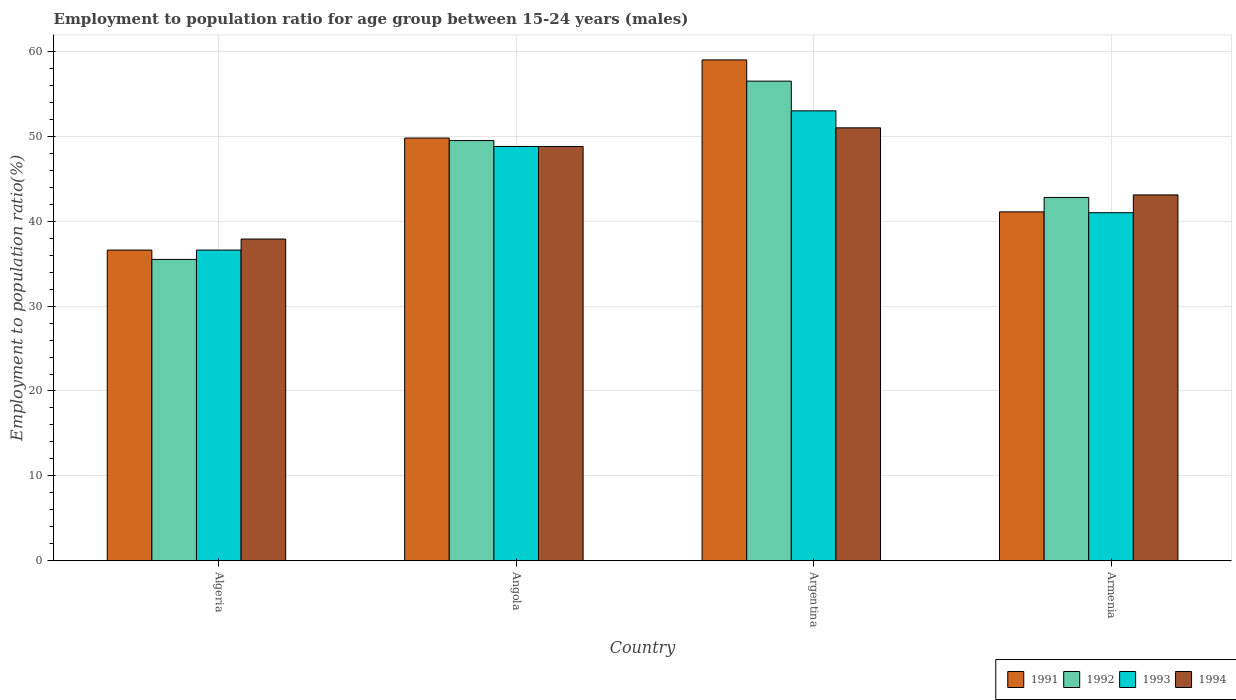How many bars are there on the 3rd tick from the left?
Ensure brevity in your answer.  4. How many bars are there on the 1st tick from the right?
Offer a very short reply. 4. What is the label of the 1st group of bars from the left?
Provide a short and direct response. Algeria. What is the employment to population ratio in 1994 in Argentina?
Ensure brevity in your answer.  51. Across all countries, what is the maximum employment to population ratio in 1991?
Offer a very short reply. 59. Across all countries, what is the minimum employment to population ratio in 1991?
Give a very brief answer. 36.6. In which country was the employment to population ratio in 1993 minimum?
Your answer should be very brief. Algeria. What is the total employment to population ratio in 1991 in the graph?
Offer a very short reply. 186.5. What is the difference between the employment to population ratio in 1994 in Armenia and the employment to population ratio in 1992 in Angola?
Your answer should be compact. -6.4. What is the average employment to population ratio in 1991 per country?
Provide a succinct answer. 46.62. What is the difference between the employment to population ratio of/in 1993 and employment to population ratio of/in 1992 in Algeria?
Your response must be concise. 1.1. What is the ratio of the employment to population ratio in 1994 in Angola to that in Argentina?
Your answer should be very brief. 0.96. Is the difference between the employment to population ratio in 1993 in Algeria and Angola greater than the difference between the employment to population ratio in 1992 in Algeria and Angola?
Keep it short and to the point. Yes. What is the difference between the highest and the second highest employment to population ratio in 1991?
Give a very brief answer. -9.2. What is the difference between the highest and the lowest employment to population ratio in 1994?
Your answer should be compact. 13.1. What does the 3rd bar from the left in Armenia represents?
Offer a terse response. 1993. Is it the case that in every country, the sum of the employment to population ratio in 1993 and employment to population ratio in 1991 is greater than the employment to population ratio in 1994?
Your response must be concise. Yes. Does the graph contain any zero values?
Make the answer very short. No. Where does the legend appear in the graph?
Provide a succinct answer. Bottom right. What is the title of the graph?
Offer a terse response. Employment to population ratio for age group between 15-24 years (males). What is the label or title of the X-axis?
Ensure brevity in your answer.  Country. What is the label or title of the Y-axis?
Your answer should be very brief. Employment to population ratio(%). What is the Employment to population ratio(%) in 1991 in Algeria?
Your response must be concise. 36.6. What is the Employment to population ratio(%) of 1992 in Algeria?
Give a very brief answer. 35.5. What is the Employment to population ratio(%) of 1993 in Algeria?
Your answer should be compact. 36.6. What is the Employment to population ratio(%) of 1994 in Algeria?
Make the answer very short. 37.9. What is the Employment to population ratio(%) of 1991 in Angola?
Offer a very short reply. 49.8. What is the Employment to population ratio(%) in 1992 in Angola?
Provide a succinct answer. 49.5. What is the Employment to population ratio(%) of 1993 in Angola?
Your response must be concise. 48.8. What is the Employment to population ratio(%) of 1994 in Angola?
Offer a terse response. 48.8. What is the Employment to population ratio(%) in 1992 in Argentina?
Keep it short and to the point. 56.5. What is the Employment to population ratio(%) of 1993 in Argentina?
Your answer should be very brief. 53. What is the Employment to population ratio(%) of 1994 in Argentina?
Your answer should be very brief. 51. What is the Employment to population ratio(%) in 1991 in Armenia?
Offer a very short reply. 41.1. What is the Employment to population ratio(%) in 1992 in Armenia?
Ensure brevity in your answer.  42.8. What is the Employment to population ratio(%) in 1994 in Armenia?
Provide a short and direct response. 43.1. Across all countries, what is the maximum Employment to population ratio(%) in 1992?
Keep it short and to the point. 56.5. Across all countries, what is the maximum Employment to population ratio(%) in 1994?
Offer a very short reply. 51. Across all countries, what is the minimum Employment to population ratio(%) in 1991?
Keep it short and to the point. 36.6. Across all countries, what is the minimum Employment to population ratio(%) of 1992?
Provide a succinct answer. 35.5. Across all countries, what is the minimum Employment to population ratio(%) of 1993?
Keep it short and to the point. 36.6. Across all countries, what is the minimum Employment to population ratio(%) of 1994?
Your answer should be very brief. 37.9. What is the total Employment to population ratio(%) in 1991 in the graph?
Offer a very short reply. 186.5. What is the total Employment to population ratio(%) in 1992 in the graph?
Make the answer very short. 184.3. What is the total Employment to population ratio(%) in 1993 in the graph?
Give a very brief answer. 179.4. What is the total Employment to population ratio(%) in 1994 in the graph?
Your response must be concise. 180.8. What is the difference between the Employment to population ratio(%) in 1991 in Algeria and that in Argentina?
Offer a terse response. -22.4. What is the difference between the Employment to population ratio(%) in 1993 in Algeria and that in Argentina?
Ensure brevity in your answer.  -16.4. What is the difference between the Employment to population ratio(%) in 1994 in Algeria and that in Argentina?
Offer a terse response. -13.1. What is the difference between the Employment to population ratio(%) in 1992 in Algeria and that in Armenia?
Your answer should be compact. -7.3. What is the difference between the Employment to population ratio(%) in 1993 in Algeria and that in Armenia?
Ensure brevity in your answer.  -4.4. What is the difference between the Employment to population ratio(%) in 1994 in Algeria and that in Armenia?
Your response must be concise. -5.2. What is the difference between the Employment to population ratio(%) in 1991 in Angola and that in Argentina?
Your answer should be very brief. -9.2. What is the difference between the Employment to population ratio(%) in 1993 in Angola and that in Argentina?
Ensure brevity in your answer.  -4.2. What is the difference between the Employment to population ratio(%) in 1993 in Angola and that in Armenia?
Make the answer very short. 7.8. What is the difference between the Employment to population ratio(%) in 1993 in Argentina and that in Armenia?
Give a very brief answer. 12. What is the difference between the Employment to population ratio(%) in 1991 in Algeria and the Employment to population ratio(%) in 1993 in Angola?
Make the answer very short. -12.2. What is the difference between the Employment to population ratio(%) of 1992 in Algeria and the Employment to population ratio(%) of 1993 in Angola?
Keep it short and to the point. -13.3. What is the difference between the Employment to population ratio(%) of 1992 in Algeria and the Employment to population ratio(%) of 1994 in Angola?
Give a very brief answer. -13.3. What is the difference between the Employment to population ratio(%) of 1993 in Algeria and the Employment to population ratio(%) of 1994 in Angola?
Offer a very short reply. -12.2. What is the difference between the Employment to population ratio(%) of 1991 in Algeria and the Employment to population ratio(%) of 1992 in Argentina?
Make the answer very short. -19.9. What is the difference between the Employment to population ratio(%) in 1991 in Algeria and the Employment to population ratio(%) in 1993 in Argentina?
Provide a succinct answer. -16.4. What is the difference between the Employment to population ratio(%) of 1991 in Algeria and the Employment to population ratio(%) of 1994 in Argentina?
Your answer should be very brief. -14.4. What is the difference between the Employment to population ratio(%) of 1992 in Algeria and the Employment to population ratio(%) of 1993 in Argentina?
Offer a very short reply. -17.5. What is the difference between the Employment to population ratio(%) of 1992 in Algeria and the Employment to population ratio(%) of 1994 in Argentina?
Your answer should be compact. -15.5. What is the difference between the Employment to population ratio(%) in 1993 in Algeria and the Employment to population ratio(%) in 1994 in Argentina?
Make the answer very short. -14.4. What is the difference between the Employment to population ratio(%) of 1991 in Algeria and the Employment to population ratio(%) of 1992 in Armenia?
Keep it short and to the point. -6.2. What is the difference between the Employment to population ratio(%) in 1991 in Algeria and the Employment to population ratio(%) in 1993 in Armenia?
Provide a succinct answer. -4.4. What is the difference between the Employment to population ratio(%) in 1992 in Algeria and the Employment to population ratio(%) in 1993 in Armenia?
Ensure brevity in your answer.  -5.5. What is the difference between the Employment to population ratio(%) in 1991 in Angola and the Employment to population ratio(%) in 1993 in Argentina?
Offer a terse response. -3.2. What is the difference between the Employment to population ratio(%) in 1991 in Angola and the Employment to population ratio(%) in 1992 in Armenia?
Make the answer very short. 7. What is the difference between the Employment to population ratio(%) of 1991 in Angola and the Employment to population ratio(%) of 1994 in Armenia?
Your answer should be compact. 6.7. What is the difference between the Employment to population ratio(%) in 1991 in Argentina and the Employment to population ratio(%) in 1992 in Armenia?
Your answer should be very brief. 16.2. What is the difference between the Employment to population ratio(%) in 1991 in Argentina and the Employment to population ratio(%) in 1993 in Armenia?
Provide a succinct answer. 18. What is the difference between the Employment to population ratio(%) in 1991 in Argentina and the Employment to population ratio(%) in 1994 in Armenia?
Ensure brevity in your answer.  15.9. What is the difference between the Employment to population ratio(%) in 1992 in Argentina and the Employment to population ratio(%) in 1993 in Armenia?
Offer a very short reply. 15.5. What is the difference between the Employment to population ratio(%) in 1992 in Argentina and the Employment to population ratio(%) in 1994 in Armenia?
Ensure brevity in your answer.  13.4. What is the average Employment to population ratio(%) of 1991 per country?
Your answer should be very brief. 46.62. What is the average Employment to population ratio(%) of 1992 per country?
Your response must be concise. 46.08. What is the average Employment to population ratio(%) in 1993 per country?
Give a very brief answer. 44.85. What is the average Employment to population ratio(%) of 1994 per country?
Your response must be concise. 45.2. What is the difference between the Employment to population ratio(%) in 1991 and Employment to population ratio(%) in 1992 in Algeria?
Give a very brief answer. 1.1. What is the difference between the Employment to population ratio(%) in 1991 and Employment to population ratio(%) in 1993 in Algeria?
Offer a terse response. 0. What is the difference between the Employment to population ratio(%) in 1991 and Employment to population ratio(%) in 1992 in Angola?
Offer a very short reply. 0.3. What is the difference between the Employment to population ratio(%) of 1991 and Employment to population ratio(%) of 1993 in Angola?
Your answer should be compact. 1. What is the difference between the Employment to population ratio(%) of 1992 and Employment to population ratio(%) of 1993 in Angola?
Your answer should be very brief. 0.7. What is the difference between the Employment to population ratio(%) in 1992 and Employment to population ratio(%) in 1993 in Argentina?
Your response must be concise. 3.5. What is the difference between the Employment to population ratio(%) of 1992 and Employment to population ratio(%) of 1994 in Argentina?
Provide a succinct answer. 5.5. What is the difference between the Employment to population ratio(%) in 1993 and Employment to population ratio(%) in 1994 in Argentina?
Your answer should be compact. 2. What is the difference between the Employment to population ratio(%) of 1991 and Employment to population ratio(%) of 1993 in Armenia?
Keep it short and to the point. 0.1. What is the difference between the Employment to population ratio(%) in 1991 and Employment to population ratio(%) in 1994 in Armenia?
Your answer should be very brief. -2. What is the difference between the Employment to population ratio(%) in 1992 and Employment to population ratio(%) in 1993 in Armenia?
Make the answer very short. 1.8. What is the difference between the Employment to population ratio(%) in 1992 and Employment to population ratio(%) in 1994 in Armenia?
Give a very brief answer. -0.3. What is the difference between the Employment to population ratio(%) of 1993 and Employment to population ratio(%) of 1994 in Armenia?
Provide a short and direct response. -2.1. What is the ratio of the Employment to population ratio(%) of 1991 in Algeria to that in Angola?
Make the answer very short. 0.73. What is the ratio of the Employment to population ratio(%) in 1992 in Algeria to that in Angola?
Keep it short and to the point. 0.72. What is the ratio of the Employment to population ratio(%) in 1994 in Algeria to that in Angola?
Offer a terse response. 0.78. What is the ratio of the Employment to population ratio(%) of 1991 in Algeria to that in Argentina?
Provide a short and direct response. 0.62. What is the ratio of the Employment to population ratio(%) of 1992 in Algeria to that in Argentina?
Give a very brief answer. 0.63. What is the ratio of the Employment to population ratio(%) in 1993 in Algeria to that in Argentina?
Give a very brief answer. 0.69. What is the ratio of the Employment to population ratio(%) of 1994 in Algeria to that in Argentina?
Your answer should be compact. 0.74. What is the ratio of the Employment to population ratio(%) of 1991 in Algeria to that in Armenia?
Your answer should be compact. 0.89. What is the ratio of the Employment to population ratio(%) of 1992 in Algeria to that in Armenia?
Offer a terse response. 0.83. What is the ratio of the Employment to population ratio(%) of 1993 in Algeria to that in Armenia?
Your answer should be very brief. 0.89. What is the ratio of the Employment to population ratio(%) of 1994 in Algeria to that in Armenia?
Your response must be concise. 0.88. What is the ratio of the Employment to population ratio(%) of 1991 in Angola to that in Argentina?
Provide a succinct answer. 0.84. What is the ratio of the Employment to population ratio(%) in 1992 in Angola to that in Argentina?
Offer a terse response. 0.88. What is the ratio of the Employment to population ratio(%) of 1993 in Angola to that in Argentina?
Offer a terse response. 0.92. What is the ratio of the Employment to population ratio(%) of 1994 in Angola to that in Argentina?
Give a very brief answer. 0.96. What is the ratio of the Employment to population ratio(%) of 1991 in Angola to that in Armenia?
Your answer should be very brief. 1.21. What is the ratio of the Employment to population ratio(%) of 1992 in Angola to that in Armenia?
Keep it short and to the point. 1.16. What is the ratio of the Employment to population ratio(%) of 1993 in Angola to that in Armenia?
Ensure brevity in your answer.  1.19. What is the ratio of the Employment to population ratio(%) of 1994 in Angola to that in Armenia?
Keep it short and to the point. 1.13. What is the ratio of the Employment to population ratio(%) in 1991 in Argentina to that in Armenia?
Keep it short and to the point. 1.44. What is the ratio of the Employment to population ratio(%) in 1992 in Argentina to that in Armenia?
Your answer should be very brief. 1.32. What is the ratio of the Employment to population ratio(%) of 1993 in Argentina to that in Armenia?
Your answer should be very brief. 1.29. What is the ratio of the Employment to population ratio(%) of 1994 in Argentina to that in Armenia?
Provide a short and direct response. 1.18. What is the difference between the highest and the second highest Employment to population ratio(%) in 1991?
Offer a terse response. 9.2. What is the difference between the highest and the second highest Employment to population ratio(%) in 1992?
Your answer should be compact. 7. What is the difference between the highest and the second highest Employment to population ratio(%) of 1994?
Make the answer very short. 2.2. What is the difference between the highest and the lowest Employment to population ratio(%) of 1991?
Offer a very short reply. 22.4. What is the difference between the highest and the lowest Employment to population ratio(%) in 1992?
Offer a terse response. 21. What is the difference between the highest and the lowest Employment to population ratio(%) in 1993?
Offer a very short reply. 16.4. What is the difference between the highest and the lowest Employment to population ratio(%) of 1994?
Provide a succinct answer. 13.1. 